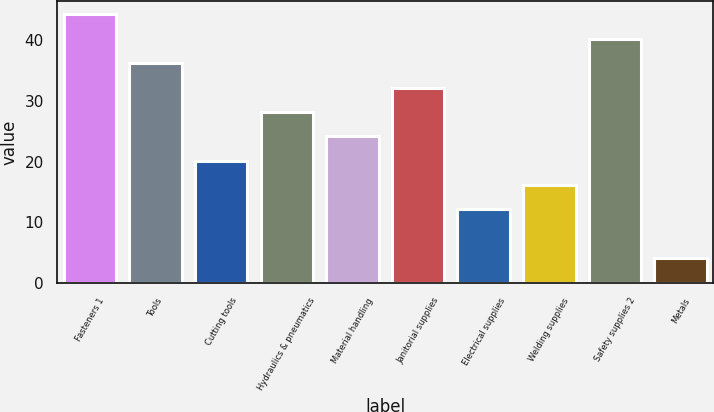Convert chart to OTSL. <chart><loc_0><loc_0><loc_500><loc_500><bar_chart><fcel>Fasteners 1<fcel>Tools<fcel>Cutting tools<fcel>Hydraulics & pneumatics<fcel>Material handling<fcel>Janitorial supplies<fcel>Electrical supplies<fcel>Welding supplies<fcel>Safety supplies 2<fcel>Metals<nl><fcel>44.21<fcel>36.19<fcel>20.15<fcel>28.17<fcel>24.16<fcel>32.18<fcel>12.13<fcel>16.14<fcel>40.2<fcel>4.11<nl></chart> 